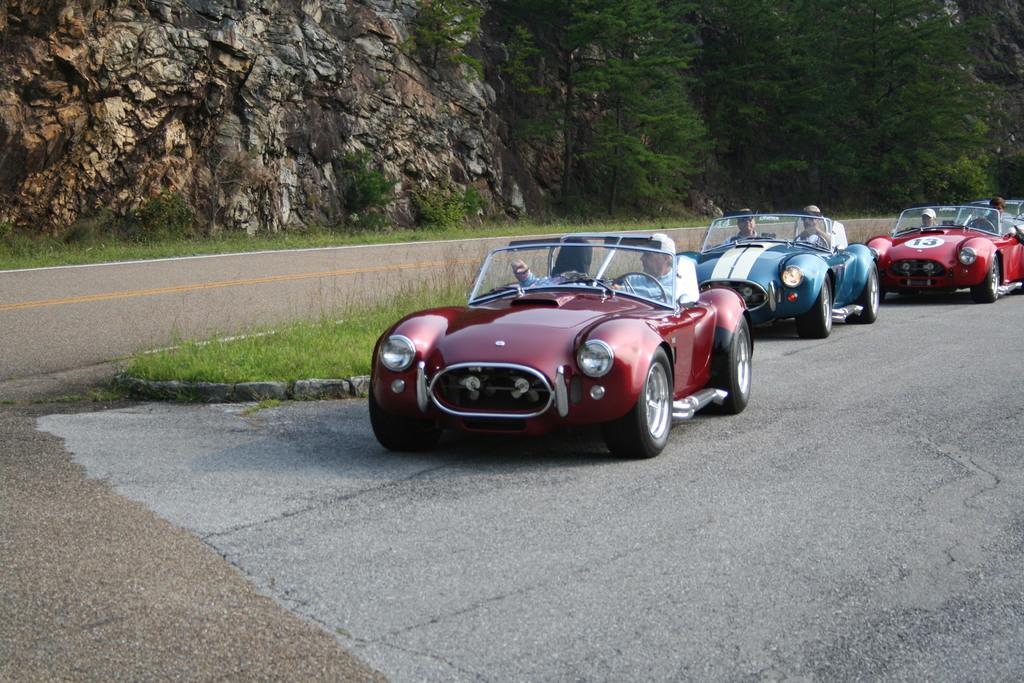What can be seen on the road in the image? There are cars on a road in the image. Who is inside the cars? People are seated in the cars. What else can be seen in the image besides the road with cars? There is another road visible in the image, as well as rocks and trees. What type of treatment is being administered to the lamp in the image? There is no lamp present in the image, so no treatment can be administered. 